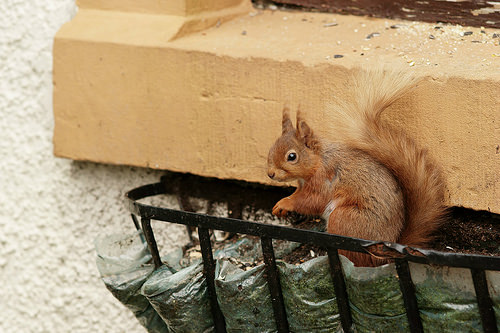<image>
Is the ledge on the squirrel? No. The ledge is not positioned on the squirrel. They may be near each other, but the ledge is not supported by or resting on top of the squirrel. Is there a squirrel in the planter? Yes. The squirrel is contained within or inside the planter, showing a containment relationship. 